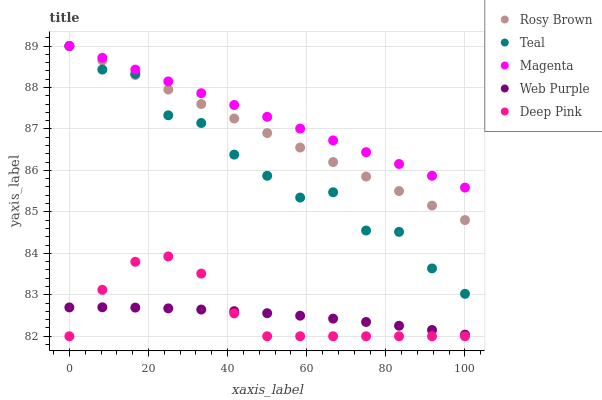Does Web Purple have the minimum area under the curve?
Answer yes or no. Yes. Does Magenta have the maximum area under the curve?
Answer yes or no. Yes. Does Rosy Brown have the minimum area under the curve?
Answer yes or no. No. Does Rosy Brown have the maximum area under the curve?
Answer yes or no. No. Is Rosy Brown the smoothest?
Answer yes or no. Yes. Is Teal the roughest?
Answer yes or no. Yes. Is Web Purple the smoothest?
Answer yes or no. No. Is Web Purple the roughest?
Answer yes or no. No. Does Deep Pink have the lowest value?
Answer yes or no. Yes. Does Rosy Brown have the lowest value?
Answer yes or no. No. Does Teal have the highest value?
Answer yes or no. Yes. Does Web Purple have the highest value?
Answer yes or no. No. Is Web Purple less than Teal?
Answer yes or no. Yes. Is Rosy Brown greater than Deep Pink?
Answer yes or no. Yes. Does Teal intersect Magenta?
Answer yes or no. Yes. Is Teal less than Magenta?
Answer yes or no. No. Is Teal greater than Magenta?
Answer yes or no. No. Does Web Purple intersect Teal?
Answer yes or no. No. 